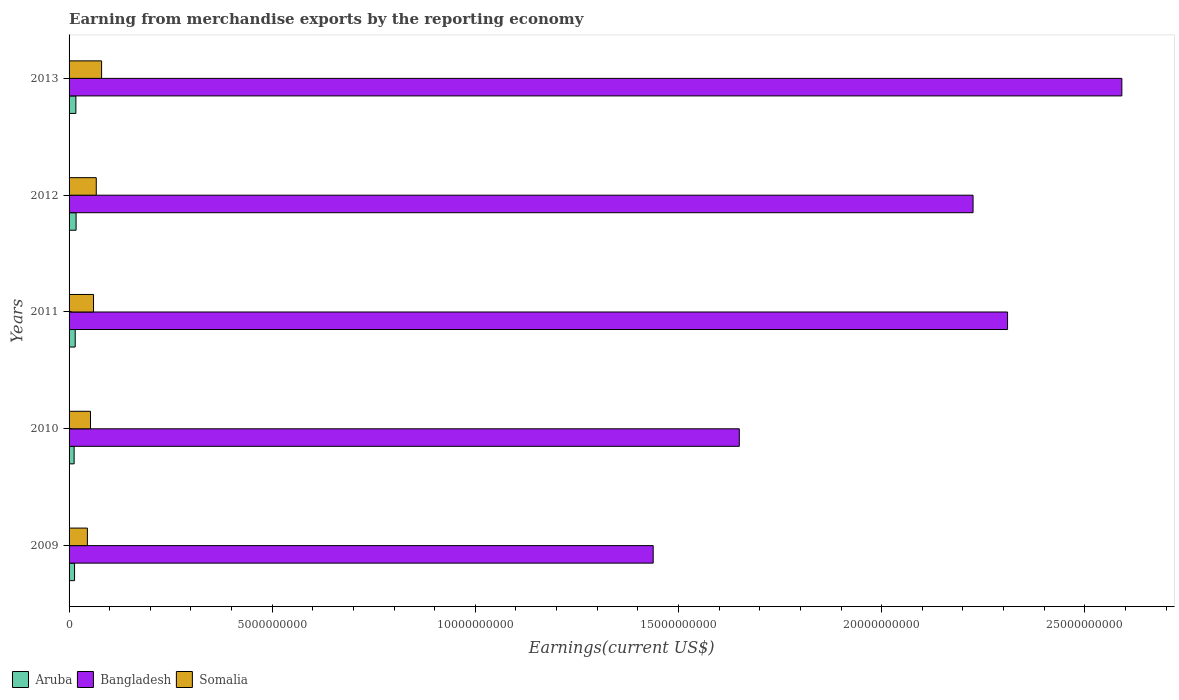What is the label of the 4th group of bars from the top?
Provide a succinct answer. 2010. In how many cases, is the number of bars for a given year not equal to the number of legend labels?
Ensure brevity in your answer.  0. What is the amount earned from merchandise exports in Somalia in 2013?
Offer a very short reply. 8.01e+08. Across all years, what is the maximum amount earned from merchandise exports in Somalia?
Ensure brevity in your answer.  8.01e+08. Across all years, what is the minimum amount earned from merchandise exports in Bangladesh?
Your response must be concise. 1.44e+1. What is the total amount earned from merchandise exports in Somalia in the graph?
Keep it short and to the point. 3.05e+09. What is the difference between the amount earned from merchandise exports in Somalia in 2010 and that in 2012?
Make the answer very short. -1.42e+08. What is the difference between the amount earned from merchandise exports in Somalia in 2010 and the amount earned from merchandise exports in Bangladesh in 2011?
Your answer should be compact. -2.26e+1. What is the average amount earned from merchandise exports in Aruba per year?
Offer a terse response. 1.50e+08. In the year 2010, what is the difference between the amount earned from merchandise exports in Aruba and amount earned from merchandise exports in Bangladesh?
Provide a succinct answer. -1.64e+1. In how many years, is the amount earned from merchandise exports in Bangladesh greater than 19000000000 US$?
Provide a short and direct response. 3. What is the ratio of the amount earned from merchandise exports in Aruba in 2010 to that in 2011?
Provide a short and direct response. 0.82. Is the difference between the amount earned from merchandise exports in Aruba in 2010 and 2011 greater than the difference between the amount earned from merchandise exports in Bangladesh in 2010 and 2011?
Give a very brief answer. Yes. What is the difference between the highest and the second highest amount earned from merchandise exports in Bangladesh?
Your answer should be compact. 2.81e+09. What is the difference between the highest and the lowest amount earned from merchandise exports in Somalia?
Offer a very short reply. 3.50e+08. In how many years, is the amount earned from merchandise exports in Somalia greater than the average amount earned from merchandise exports in Somalia taken over all years?
Your response must be concise. 2. What does the 1st bar from the top in 2009 represents?
Ensure brevity in your answer.  Somalia. Is it the case that in every year, the sum of the amount earned from merchandise exports in Somalia and amount earned from merchandise exports in Aruba is greater than the amount earned from merchandise exports in Bangladesh?
Offer a terse response. No. How many bars are there?
Offer a terse response. 15. How many years are there in the graph?
Offer a very short reply. 5. What is the difference between two consecutive major ticks on the X-axis?
Your response must be concise. 5.00e+09. How many legend labels are there?
Keep it short and to the point. 3. What is the title of the graph?
Give a very brief answer. Earning from merchandise exports by the reporting economy. Does "Virgin Islands" appear as one of the legend labels in the graph?
Keep it short and to the point. No. What is the label or title of the X-axis?
Keep it short and to the point. Earnings(current US$). What is the label or title of the Y-axis?
Your answer should be compact. Years. What is the Earnings(current US$) of Aruba in 2009?
Provide a succinct answer. 1.35e+08. What is the Earnings(current US$) of Bangladesh in 2009?
Keep it short and to the point. 1.44e+1. What is the Earnings(current US$) of Somalia in 2009?
Your response must be concise. 4.51e+08. What is the Earnings(current US$) of Aruba in 2010?
Offer a terse response. 1.25e+08. What is the Earnings(current US$) of Bangladesh in 2010?
Make the answer very short. 1.65e+1. What is the Earnings(current US$) in Somalia in 2010?
Offer a very short reply. 5.27e+08. What is the Earnings(current US$) of Aruba in 2011?
Provide a short and direct response. 1.51e+08. What is the Earnings(current US$) in Bangladesh in 2011?
Give a very brief answer. 2.31e+1. What is the Earnings(current US$) in Somalia in 2011?
Your answer should be compact. 6.02e+08. What is the Earnings(current US$) of Aruba in 2012?
Offer a very short reply. 1.73e+08. What is the Earnings(current US$) of Bangladesh in 2012?
Keep it short and to the point. 2.23e+1. What is the Earnings(current US$) in Somalia in 2012?
Make the answer very short. 6.69e+08. What is the Earnings(current US$) in Aruba in 2013?
Your answer should be compact. 1.68e+08. What is the Earnings(current US$) in Bangladesh in 2013?
Make the answer very short. 2.59e+1. What is the Earnings(current US$) of Somalia in 2013?
Provide a short and direct response. 8.01e+08. Across all years, what is the maximum Earnings(current US$) in Aruba?
Give a very brief answer. 1.73e+08. Across all years, what is the maximum Earnings(current US$) in Bangladesh?
Provide a short and direct response. 2.59e+1. Across all years, what is the maximum Earnings(current US$) of Somalia?
Make the answer very short. 8.01e+08. Across all years, what is the minimum Earnings(current US$) in Aruba?
Your answer should be very brief. 1.25e+08. Across all years, what is the minimum Earnings(current US$) of Bangladesh?
Your answer should be compact. 1.44e+1. Across all years, what is the minimum Earnings(current US$) of Somalia?
Your answer should be compact. 4.51e+08. What is the total Earnings(current US$) of Aruba in the graph?
Ensure brevity in your answer.  7.51e+08. What is the total Earnings(current US$) in Bangladesh in the graph?
Keep it short and to the point. 1.02e+11. What is the total Earnings(current US$) of Somalia in the graph?
Your response must be concise. 3.05e+09. What is the difference between the Earnings(current US$) in Aruba in 2009 and that in 2010?
Keep it short and to the point. 1.07e+07. What is the difference between the Earnings(current US$) of Bangladesh in 2009 and that in 2010?
Keep it short and to the point. -2.12e+09. What is the difference between the Earnings(current US$) of Somalia in 2009 and that in 2010?
Offer a very short reply. -7.63e+07. What is the difference between the Earnings(current US$) in Aruba in 2009 and that in 2011?
Ensure brevity in your answer.  -1.61e+07. What is the difference between the Earnings(current US$) in Bangladesh in 2009 and that in 2011?
Your answer should be compact. -8.72e+09. What is the difference between the Earnings(current US$) of Somalia in 2009 and that in 2011?
Your answer should be very brief. -1.51e+08. What is the difference between the Earnings(current US$) of Aruba in 2009 and that in 2012?
Your answer should be compact. -3.75e+07. What is the difference between the Earnings(current US$) in Bangladesh in 2009 and that in 2012?
Your answer should be compact. -7.87e+09. What is the difference between the Earnings(current US$) of Somalia in 2009 and that in 2012?
Ensure brevity in your answer.  -2.18e+08. What is the difference between the Earnings(current US$) in Aruba in 2009 and that in 2013?
Provide a short and direct response. -3.24e+07. What is the difference between the Earnings(current US$) in Bangladesh in 2009 and that in 2013?
Offer a very short reply. -1.15e+1. What is the difference between the Earnings(current US$) of Somalia in 2009 and that in 2013?
Provide a short and direct response. -3.50e+08. What is the difference between the Earnings(current US$) of Aruba in 2010 and that in 2011?
Offer a terse response. -2.68e+07. What is the difference between the Earnings(current US$) in Bangladesh in 2010 and that in 2011?
Keep it short and to the point. -6.60e+09. What is the difference between the Earnings(current US$) of Somalia in 2010 and that in 2011?
Ensure brevity in your answer.  -7.49e+07. What is the difference between the Earnings(current US$) in Aruba in 2010 and that in 2012?
Offer a very short reply. -4.82e+07. What is the difference between the Earnings(current US$) in Bangladesh in 2010 and that in 2012?
Give a very brief answer. -5.75e+09. What is the difference between the Earnings(current US$) of Somalia in 2010 and that in 2012?
Ensure brevity in your answer.  -1.42e+08. What is the difference between the Earnings(current US$) in Aruba in 2010 and that in 2013?
Give a very brief answer. -4.31e+07. What is the difference between the Earnings(current US$) of Bangladesh in 2010 and that in 2013?
Your answer should be very brief. -9.42e+09. What is the difference between the Earnings(current US$) in Somalia in 2010 and that in 2013?
Provide a succinct answer. -2.73e+08. What is the difference between the Earnings(current US$) in Aruba in 2011 and that in 2012?
Provide a succinct answer. -2.14e+07. What is the difference between the Earnings(current US$) of Bangladesh in 2011 and that in 2012?
Your answer should be very brief. 8.49e+08. What is the difference between the Earnings(current US$) in Somalia in 2011 and that in 2012?
Your answer should be compact. -6.70e+07. What is the difference between the Earnings(current US$) in Aruba in 2011 and that in 2013?
Your answer should be compact. -1.63e+07. What is the difference between the Earnings(current US$) of Bangladesh in 2011 and that in 2013?
Ensure brevity in your answer.  -2.81e+09. What is the difference between the Earnings(current US$) in Somalia in 2011 and that in 2013?
Make the answer very short. -1.98e+08. What is the difference between the Earnings(current US$) in Aruba in 2012 and that in 2013?
Make the answer very short. 5.07e+06. What is the difference between the Earnings(current US$) of Bangladesh in 2012 and that in 2013?
Give a very brief answer. -3.66e+09. What is the difference between the Earnings(current US$) in Somalia in 2012 and that in 2013?
Your answer should be compact. -1.31e+08. What is the difference between the Earnings(current US$) of Aruba in 2009 and the Earnings(current US$) of Bangladesh in 2010?
Make the answer very short. -1.64e+1. What is the difference between the Earnings(current US$) of Aruba in 2009 and the Earnings(current US$) of Somalia in 2010?
Provide a short and direct response. -3.92e+08. What is the difference between the Earnings(current US$) of Bangladesh in 2009 and the Earnings(current US$) of Somalia in 2010?
Your response must be concise. 1.39e+1. What is the difference between the Earnings(current US$) in Aruba in 2009 and the Earnings(current US$) in Bangladesh in 2011?
Make the answer very short. -2.30e+1. What is the difference between the Earnings(current US$) in Aruba in 2009 and the Earnings(current US$) in Somalia in 2011?
Offer a very short reply. -4.67e+08. What is the difference between the Earnings(current US$) of Bangladesh in 2009 and the Earnings(current US$) of Somalia in 2011?
Your answer should be compact. 1.38e+1. What is the difference between the Earnings(current US$) of Aruba in 2009 and the Earnings(current US$) of Bangladesh in 2012?
Keep it short and to the point. -2.21e+1. What is the difference between the Earnings(current US$) of Aruba in 2009 and the Earnings(current US$) of Somalia in 2012?
Offer a terse response. -5.34e+08. What is the difference between the Earnings(current US$) in Bangladesh in 2009 and the Earnings(current US$) in Somalia in 2012?
Offer a very short reply. 1.37e+1. What is the difference between the Earnings(current US$) of Aruba in 2009 and the Earnings(current US$) of Bangladesh in 2013?
Ensure brevity in your answer.  -2.58e+1. What is the difference between the Earnings(current US$) of Aruba in 2009 and the Earnings(current US$) of Somalia in 2013?
Your answer should be compact. -6.65e+08. What is the difference between the Earnings(current US$) of Bangladesh in 2009 and the Earnings(current US$) of Somalia in 2013?
Keep it short and to the point. 1.36e+1. What is the difference between the Earnings(current US$) of Aruba in 2010 and the Earnings(current US$) of Bangladesh in 2011?
Your answer should be compact. -2.30e+1. What is the difference between the Earnings(current US$) of Aruba in 2010 and the Earnings(current US$) of Somalia in 2011?
Your answer should be very brief. -4.78e+08. What is the difference between the Earnings(current US$) in Bangladesh in 2010 and the Earnings(current US$) in Somalia in 2011?
Offer a terse response. 1.59e+1. What is the difference between the Earnings(current US$) of Aruba in 2010 and the Earnings(current US$) of Bangladesh in 2012?
Give a very brief answer. -2.21e+1. What is the difference between the Earnings(current US$) in Aruba in 2010 and the Earnings(current US$) in Somalia in 2012?
Your response must be concise. -5.45e+08. What is the difference between the Earnings(current US$) in Bangladesh in 2010 and the Earnings(current US$) in Somalia in 2012?
Provide a short and direct response. 1.58e+1. What is the difference between the Earnings(current US$) in Aruba in 2010 and the Earnings(current US$) in Bangladesh in 2013?
Offer a very short reply. -2.58e+1. What is the difference between the Earnings(current US$) in Aruba in 2010 and the Earnings(current US$) in Somalia in 2013?
Ensure brevity in your answer.  -6.76e+08. What is the difference between the Earnings(current US$) of Bangladesh in 2010 and the Earnings(current US$) of Somalia in 2013?
Give a very brief answer. 1.57e+1. What is the difference between the Earnings(current US$) in Aruba in 2011 and the Earnings(current US$) in Bangladesh in 2012?
Provide a succinct answer. -2.21e+1. What is the difference between the Earnings(current US$) in Aruba in 2011 and the Earnings(current US$) in Somalia in 2012?
Your answer should be compact. -5.18e+08. What is the difference between the Earnings(current US$) of Bangladesh in 2011 and the Earnings(current US$) of Somalia in 2012?
Ensure brevity in your answer.  2.24e+1. What is the difference between the Earnings(current US$) in Aruba in 2011 and the Earnings(current US$) in Bangladesh in 2013?
Offer a very short reply. -2.58e+1. What is the difference between the Earnings(current US$) of Aruba in 2011 and the Earnings(current US$) of Somalia in 2013?
Your answer should be compact. -6.49e+08. What is the difference between the Earnings(current US$) in Bangladesh in 2011 and the Earnings(current US$) in Somalia in 2013?
Provide a succinct answer. 2.23e+1. What is the difference between the Earnings(current US$) of Aruba in 2012 and the Earnings(current US$) of Bangladesh in 2013?
Make the answer very short. -2.57e+1. What is the difference between the Earnings(current US$) in Aruba in 2012 and the Earnings(current US$) in Somalia in 2013?
Your answer should be very brief. -6.28e+08. What is the difference between the Earnings(current US$) of Bangladesh in 2012 and the Earnings(current US$) of Somalia in 2013?
Offer a very short reply. 2.15e+1. What is the average Earnings(current US$) in Aruba per year?
Make the answer very short. 1.50e+08. What is the average Earnings(current US$) in Bangladesh per year?
Offer a very short reply. 2.04e+1. What is the average Earnings(current US$) of Somalia per year?
Your response must be concise. 6.10e+08. In the year 2009, what is the difference between the Earnings(current US$) in Aruba and Earnings(current US$) in Bangladesh?
Provide a short and direct response. -1.42e+1. In the year 2009, what is the difference between the Earnings(current US$) in Aruba and Earnings(current US$) in Somalia?
Keep it short and to the point. -3.16e+08. In the year 2009, what is the difference between the Earnings(current US$) in Bangladesh and Earnings(current US$) in Somalia?
Ensure brevity in your answer.  1.39e+1. In the year 2010, what is the difference between the Earnings(current US$) in Aruba and Earnings(current US$) in Bangladesh?
Your answer should be very brief. -1.64e+1. In the year 2010, what is the difference between the Earnings(current US$) of Aruba and Earnings(current US$) of Somalia?
Your answer should be compact. -4.03e+08. In the year 2010, what is the difference between the Earnings(current US$) in Bangladesh and Earnings(current US$) in Somalia?
Provide a short and direct response. 1.60e+1. In the year 2011, what is the difference between the Earnings(current US$) in Aruba and Earnings(current US$) in Bangladesh?
Your response must be concise. -2.29e+1. In the year 2011, what is the difference between the Earnings(current US$) of Aruba and Earnings(current US$) of Somalia?
Your answer should be very brief. -4.51e+08. In the year 2011, what is the difference between the Earnings(current US$) of Bangladesh and Earnings(current US$) of Somalia?
Ensure brevity in your answer.  2.25e+1. In the year 2012, what is the difference between the Earnings(current US$) of Aruba and Earnings(current US$) of Bangladesh?
Offer a very short reply. -2.21e+1. In the year 2012, what is the difference between the Earnings(current US$) of Aruba and Earnings(current US$) of Somalia?
Offer a very short reply. -4.97e+08. In the year 2012, what is the difference between the Earnings(current US$) in Bangladesh and Earnings(current US$) in Somalia?
Ensure brevity in your answer.  2.16e+1. In the year 2013, what is the difference between the Earnings(current US$) in Aruba and Earnings(current US$) in Bangladesh?
Keep it short and to the point. -2.57e+1. In the year 2013, what is the difference between the Earnings(current US$) in Aruba and Earnings(current US$) in Somalia?
Your answer should be very brief. -6.33e+08. In the year 2013, what is the difference between the Earnings(current US$) in Bangladesh and Earnings(current US$) in Somalia?
Offer a terse response. 2.51e+1. What is the ratio of the Earnings(current US$) in Aruba in 2009 to that in 2010?
Your answer should be very brief. 1.09. What is the ratio of the Earnings(current US$) of Bangladesh in 2009 to that in 2010?
Offer a very short reply. 0.87. What is the ratio of the Earnings(current US$) in Somalia in 2009 to that in 2010?
Your answer should be very brief. 0.86. What is the ratio of the Earnings(current US$) of Aruba in 2009 to that in 2011?
Provide a short and direct response. 0.89. What is the ratio of the Earnings(current US$) in Bangladesh in 2009 to that in 2011?
Offer a very short reply. 0.62. What is the ratio of the Earnings(current US$) of Somalia in 2009 to that in 2011?
Your answer should be compact. 0.75. What is the ratio of the Earnings(current US$) of Aruba in 2009 to that in 2012?
Offer a terse response. 0.78. What is the ratio of the Earnings(current US$) in Bangladesh in 2009 to that in 2012?
Offer a very short reply. 0.65. What is the ratio of the Earnings(current US$) of Somalia in 2009 to that in 2012?
Offer a very short reply. 0.67. What is the ratio of the Earnings(current US$) of Aruba in 2009 to that in 2013?
Give a very brief answer. 0.81. What is the ratio of the Earnings(current US$) in Bangladesh in 2009 to that in 2013?
Provide a succinct answer. 0.55. What is the ratio of the Earnings(current US$) of Somalia in 2009 to that in 2013?
Keep it short and to the point. 0.56. What is the ratio of the Earnings(current US$) in Aruba in 2010 to that in 2011?
Provide a short and direct response. 0.82. What is the ratio of the Earnings(current US$) of Bangladesh in 2010 to that in 2011?
Make the answer very short. 0.71. What is the ratio of the Earnings(current US$) of Somalia in 2010 to that in 2011?
Give a very brief answer. 0.88. What is the ratio of the Earnings(current US$) of Aruba in 2010 to that in 2012?
Provide a succinct answer. 0.72. What is the ratio of the Earnings(current US$) of Bangladesh in 2010 to that in 2012?
Your response must be concise. 0.74. What is the ratio of the Earnings(current US$) of Somalia in 2010 to that in 2012?
Make the answer very short. 0.79. What is the ratio of the Earnings(current US$) of Aruba in 2010 to that in 2013?
Offer a terse response. 0.74. What is the ratio of the Earnings(current US$) in Bangladesh in 2010 to that in 2013?
Offer a terse response. 0.64. What is the ratio of the Earnings(current US$) of Somalia in 2010 to that in 2013?
Keep it short and to the point. 0.66. What is the ratio of the Earnings(current US$) of Aruba in 2011 to that in 2012?
Your answer should be compact. 0.88. What is the ratio of the Earnings(current US$) in Bangladesh in 2011 to that in 2012?
Provide a short and direct response. 1.04. What is the ratio of the Earnings(current US$) in Somalia in 2011 to that in 2012?
Your answer should be compact. 0.9. What is the ratio of the Earnings(current US$) in Aruba in 2011 to that in 2013?
Your answer should be very brief. 0.9. What is the ratio of the Earnings(current US$) in Bangladesh in 2011 to that in 2013?
Your answer should be very brief. 0.89. What is the ratio of the Earnings(current US$) in Somalia in 2011 to that in 2013?
Give a very brief answer. 0.75. What is the ratio of the Earnings(current US$) of Aruba in 2012 to that in 2013?
Your response must be concise. 1.03. What is the ratio of the Earnings(current US$) in Bangladesh in 2012 to that in 2013?
Your answer should be compact. 0.86. What is the ratio of the Earnings(current US$) of Somalia in 2012 to that in 2013?
Your answer should be compact. 0.84. What is the difference between the highest and the second highest Earnings(current US$) of Aruba?
Provide a short and direct response. 5.07e+06. What is the difference between the highest and the second highest Earnings(current US$) in Bangladesh?
Your answer should be very brief. 2.81e+09. What is the difference between the highest and the second highest Earnings(current US$) of Somalia?
Give a very brief answer. 1.31e+08. What is the difference between the highest and the lowest Earnings(current US$) of Aruba?
Provide a succinct answer. 4.82e+07. What is the difference between the highest and the lowest Earnings(current US$) of Bangladesh?
Offer a terse response. 1.15e+1. What is the difference between the highest and the lowest Earnings(current US$) in Somalia?
Provide a succinct answer. 3.50e+08. 